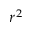Convert formula to latex. <formula><loc_0><loc_0><loc_500><loc_500>r ^ { 2 }</formula> 